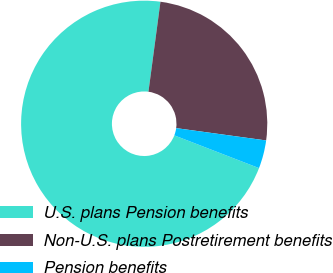<chart> <loc_0><loc_0><loc_500><loc_500><pie_chart><fcel>U.S. plans Pension benefits<fcel>Non-U.S. plans Postretirement benefits<fcel>Pension benefits<nl><fcel>71.24%<fcel>25.06%<fcel>3.7%<nl></chart> 